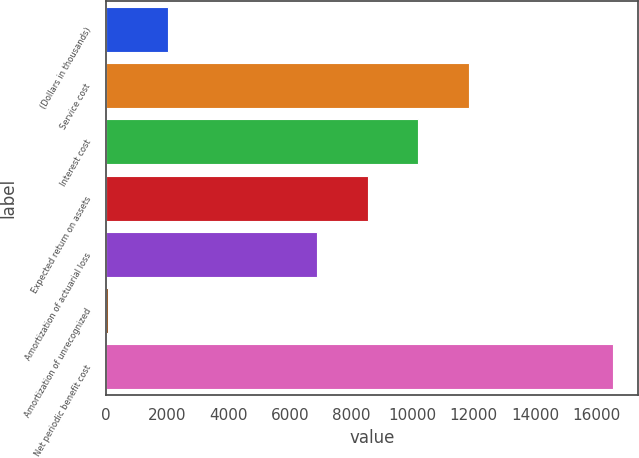Convert chart to OTSL. <chart><loc_0><loc_0><loc_500><loc_500><bar_chart><fcel>(Dollars in thousands)<fcel>Service cost<fcel>Interest cost<fcel>Expected return on assets<fcel>Amortization of actuarial loss<fcel>Amortization of unrecognized<fcel>Net periodic benefit cost<nl><fcel>2012<fcel>11843.9<fcel>10194.6<fcel>8545.3<fcel>6896<fcel>49<fcel>16542<nl></chart> 